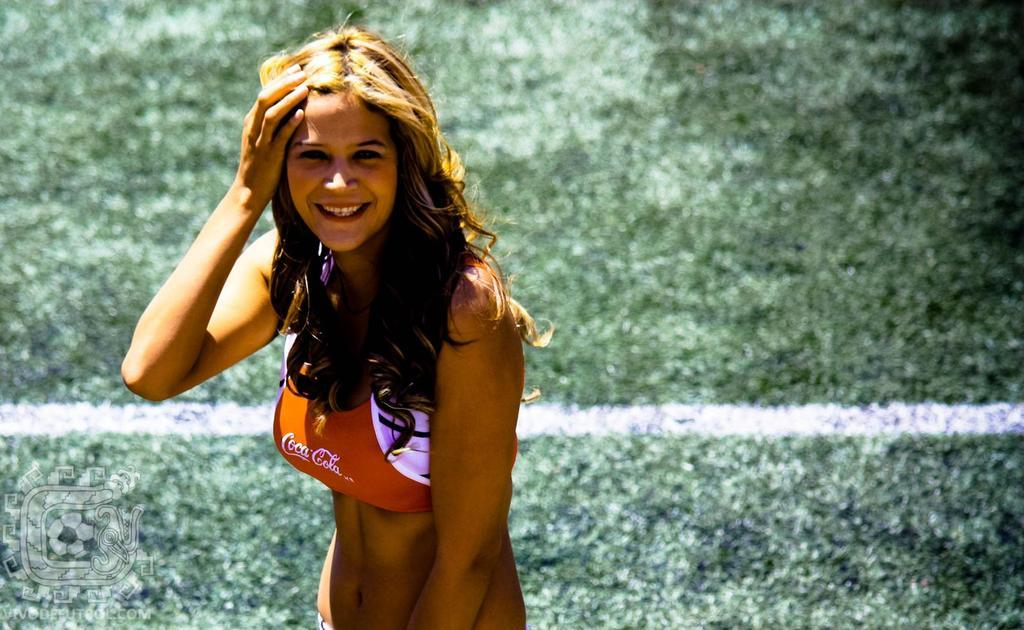What is the woman in the image doing? The woman is standing in the image and smiling. Can you describe the color of the line on the ground in the background? The line on the ground in the background is white. What is present in the image that might not be visible at first glance? There is a watermark in the image. How much money is the woman holding in the image? There is no indication of money in the image, so we cannot determine how much the woman is holding. Is there a cave visible in the background of the image? No, there is no cave present in the image; it features a woman standing with a white line on the ground in the background. 